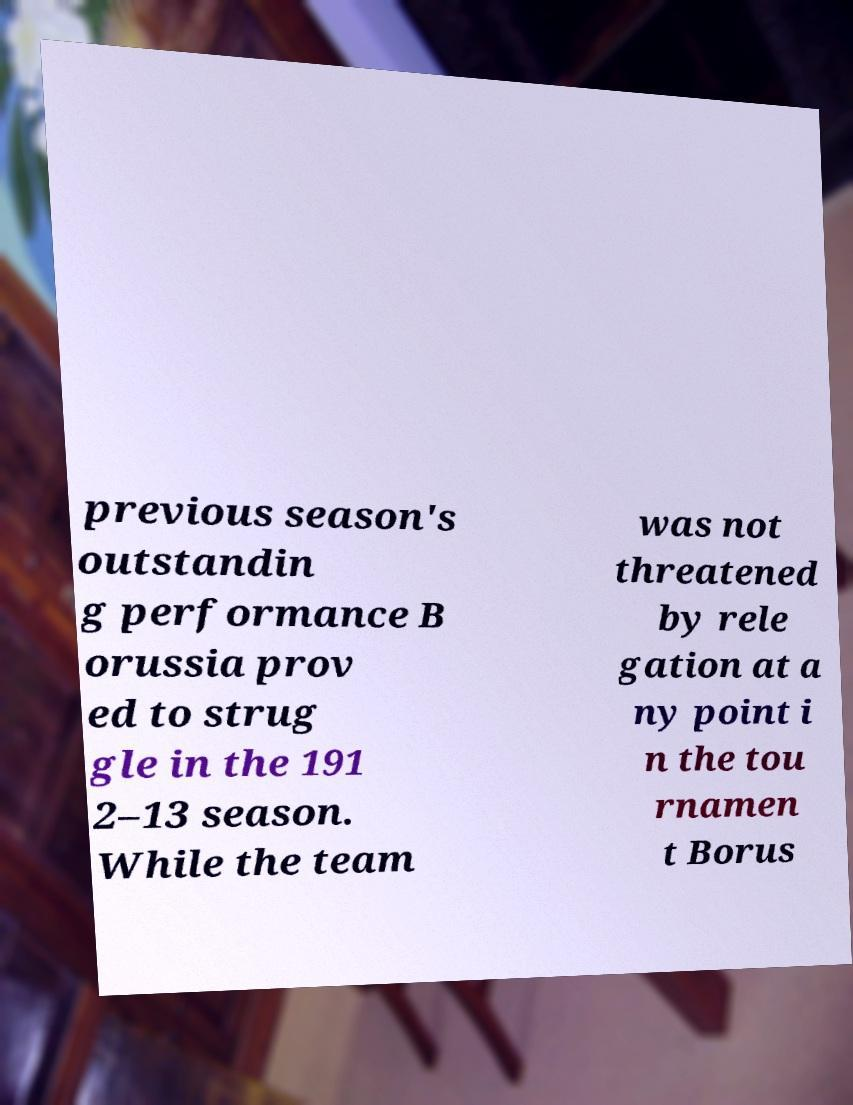Can you accurately transcribe the text from the provided image for me? previous season's outstandin g performance B orussia prov ed to strug gle in the 191 2–13 season. While the team was not threatened by rele gation at a ny point i n the tou rnamen t Borus 